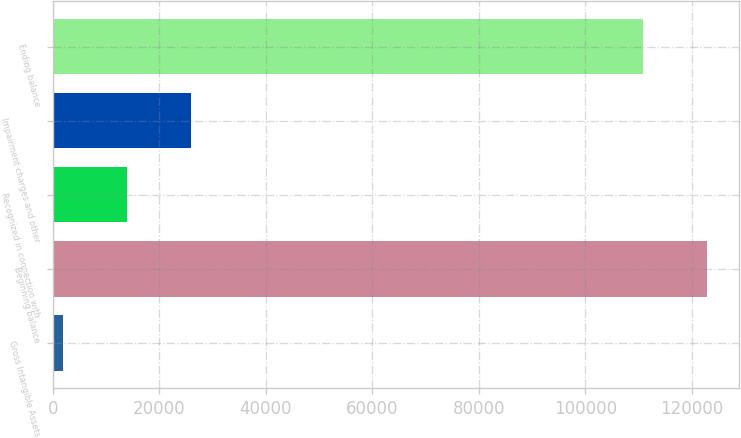Convert chart to OTSL. <chart><loc_0><loc_0><loc_500><loc_500><bar_chart><fcel>Gross Intangible Assets<fcel>Beginning balance<fcel>Recognized in connection with<fcel>Impairment charges and other<fcel>Ending balance<nl><fcel>2006<fcel>122737<fcel>13978.9<fcel>25951.8<fcel>110764<nl></chart> 